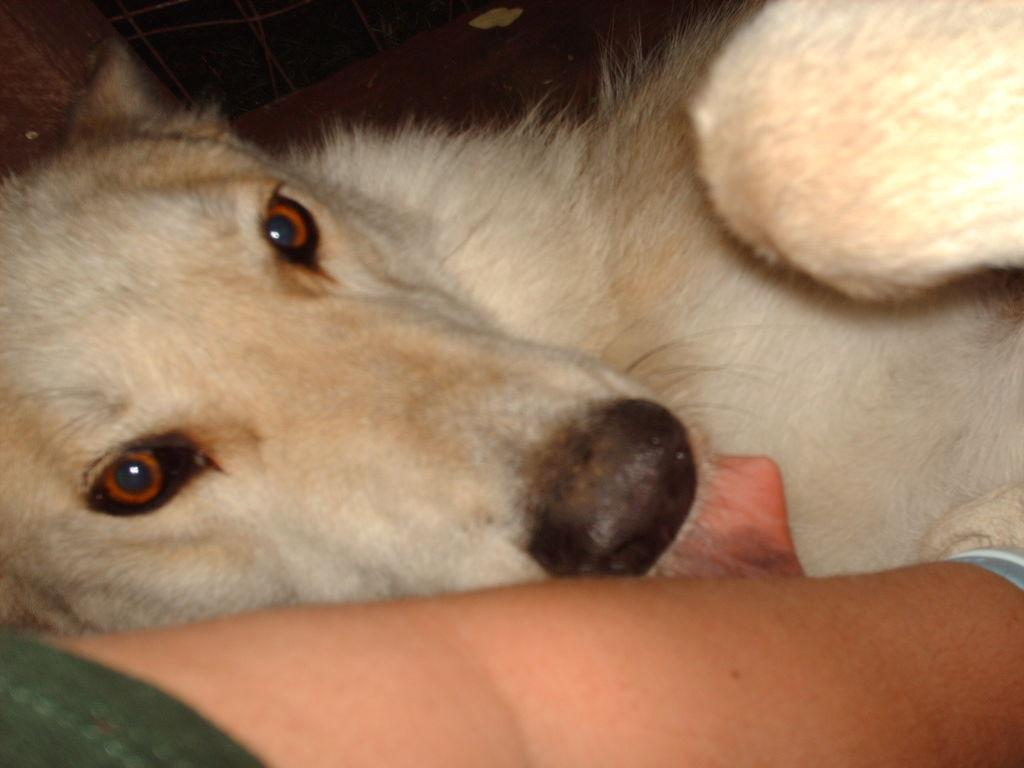What type of animal is present in the image? There is a dog in the image. What is the dog doing in the image? The dog is laying over a place. What type of note is the dog holding in the image? There is no note present in the image, as it features a dog laying over a place. 